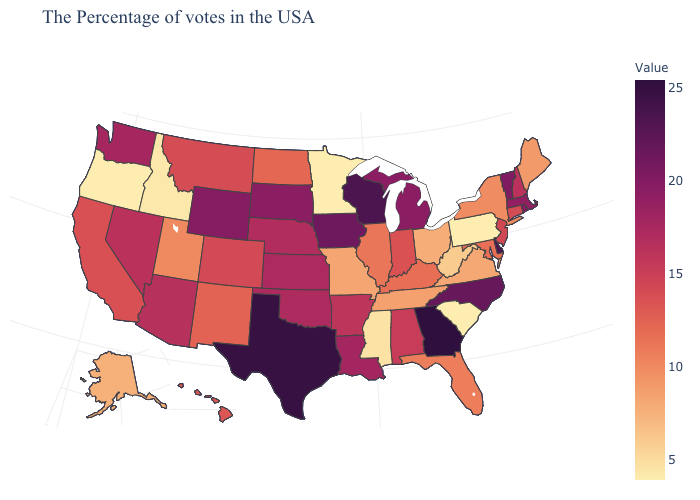Among the states that border South Carolina , does North Carolina have the lowest value?
Write a very short answer. Yes. Does Oregon have the lowest value in the West?
Be succinct. Yes. Does the map have missing data?
Answer briefly. No. Among the states that border Alabama , does Florida have the lowest value?
Concise answer only. No. Among the states that border Wyoming , does Idaho have the lowest value?
Concise answer only. Yes. Which states have the lowest value in the USA?
Answer briefly. Pennsylvania, South Carolina, Minnesota, Oregon. 